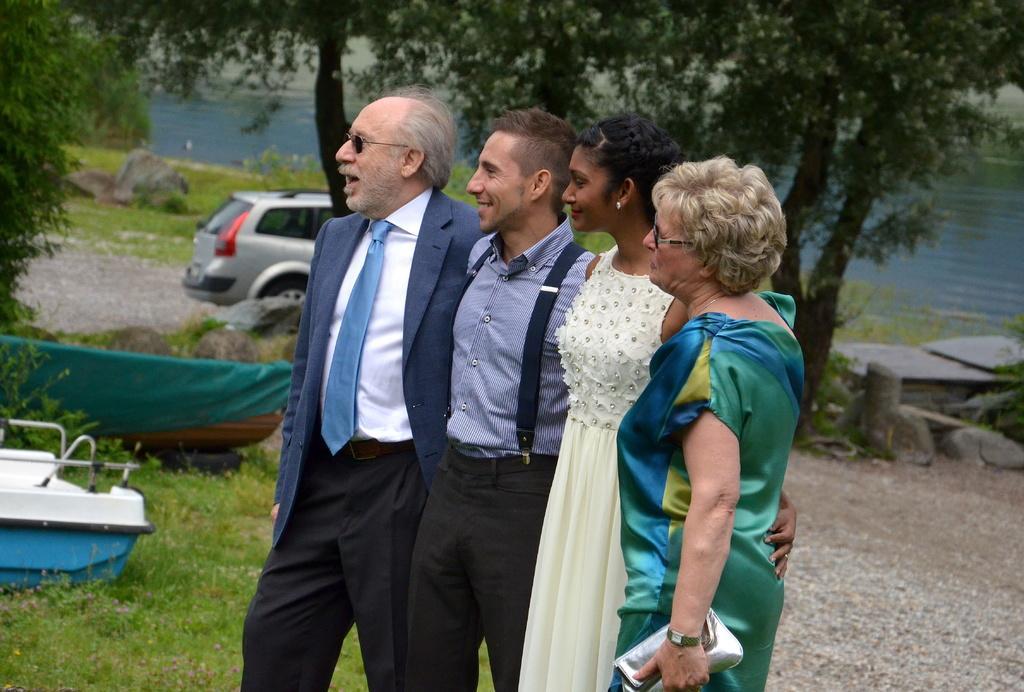Could you give a brief overview of what you see in this image? In the center of the image we can see four people are standing and they are in different costumes. Among them, we can see three persons are smiling and one person is holding some object. In the background, we can see trees, grass, water, rocks, one vehicle and boats. 